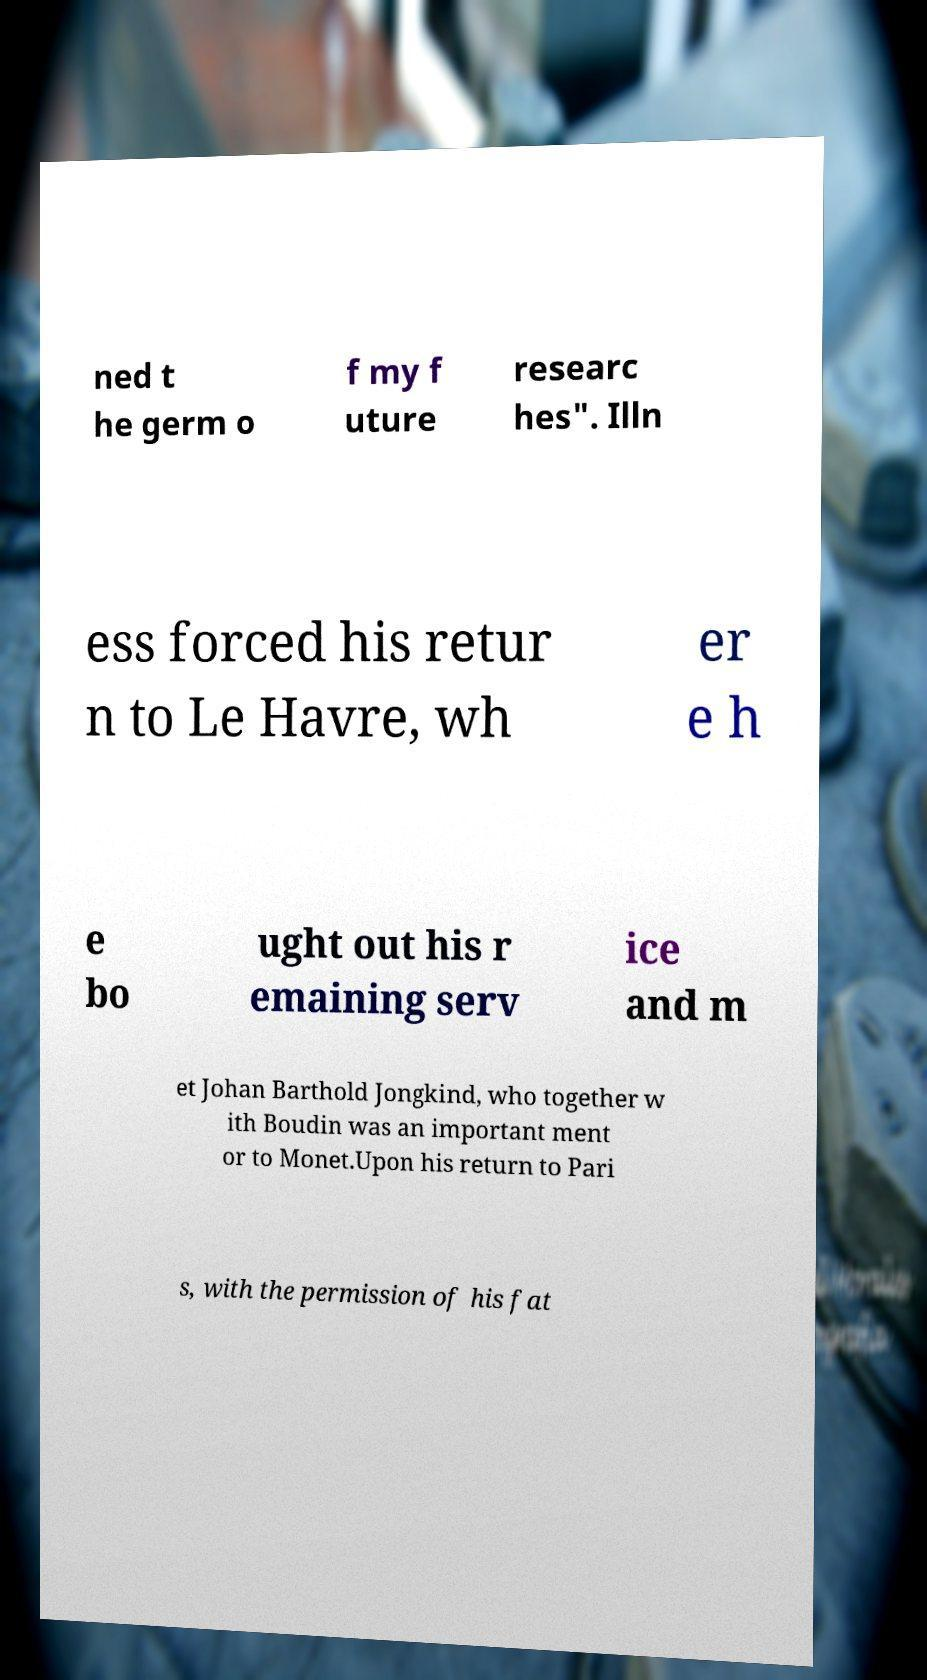Could you extract and type out the text from this image? ned t he germ o f my f uture researc hes". Illn ess forced his retur n to Le Havre, wh er e h e bo ught out his r emaining serv ice and m et Johan Barthold Jongkind, who together w ith Boudin was an important ment or to Monet.Upon his return to Pari s, with the permission of his fat 